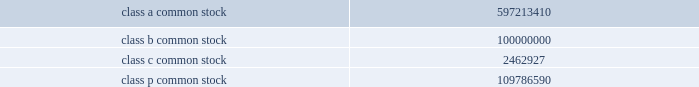Kinder morgan , inc .
Form 10-k indicate by check mark whether the registrant ( 1 ) has filed all reports required to be filed by section 13 or 15 ( d ) of the securities exchange act of 1934 during the preceding 12 months ( or for such shorter period that the registrant was required to file such reports ) , and ( 2 ) has been subject to such filing requirements for the past 90 days .
Yes f06f no f0fe indicate by check mark whether the registrant has submitted electronically and posted on its corporate website , if any , every interactive data file required to be submitted and posted pursuant to rule 405 of regulation s-t during the preceding 12 months ( or for such shorter period that the registrant was required to submit and post such files ) .
Yes f06f no f06f indicate by check mark if disclosure of delinquent filers pursuant to item 405 of regulation s-k is not contained herein , and will not be contained , to the best of registrant 2019s knowledge , in definitive proxy or information statements incorporated by reference in part iii of this form 10-k or any amendment to this form 10-k .
F0fe indicate by check mark whether the registrant is a large accelerated filer , an accelerated filer , a non-accelerated filer , or a smaller reporting company ( as defined in rule 12b-2 of the securities exchange act of 1934 ) .
Large accelerated filer f06f accelerated filer f06f non-accelerated filer f0fe smaller reporting company f06f indicate by check mark whether the registrant is a shell company ( as defined in rule 12b-2 of the securities exchange act of 1934 ) .
Yes f06f no f0fe as of june 30 , 2010 , the registrant was a privately held company , and therefore the market value of its common equity held by nonaffiliates was zero .
As of february 16 , 2011 , the registrant had the following number of shares of common stock outstanding: .
Explanatory note prior to the consummation of its february 2011 initial public offering , kinder morgan , inc. , was a delaware limited liability company named kinder morgan holdco llc whose unitholders became stockholders of kinder morgan , inc .
Upon the completion of its initial public offering .
Except as disclosed in the accompanying report , the consolidated financial statements and selected historical consolidated financial data and other historical financial information included in this report are those of kinder morgan holdco llc or its predecessor and their respective subsidiaries and do not give effect to the conversion .
Kinder morgan holdco llc 2019s wholly owned subsidiary , kinder morgan , inc. , who was not the registrant under our initial public offering , has changed its name to kinder morgan kansas , inc. .
What is the total number of shares of common stock outstanding? 
Computations: (((597213410 + 100000000) + 2462927) + 109786590)
Answer: 809462927.0. 